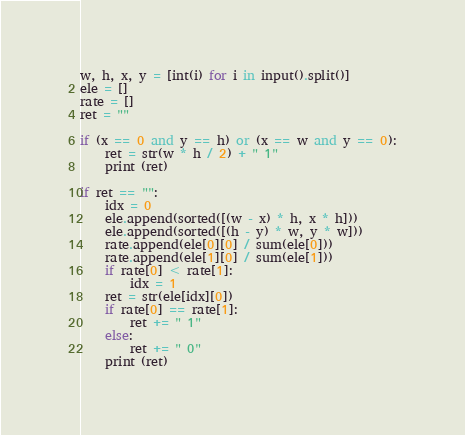Convert code to text. <code><loc_0><loc_0><loc_500><loc_500><_Python_>w, h, x, y = [int(i) for i in input().split()]
ele = []
rate = []
ret = ""

if (x == 0 and y == h) or (x == w and y == 0):
	ret = str(w * h / 2) + " 1"
	print (ret)

if ret == "":
    idx = 0
    ele.append(sorted([(w - x) * h, x * h]))
    ele.append(sorted([(h - y) * w, y * w]))
    rate.append(ele[0][0] / sum(ele[0]))
    rate.append(ele[1][0] / sum(ele[1]))
    if rate[0] < rate[1]:
        idx = 1
    ret = str(ele[idx][0])
    if rate[0] == rate[1]:
        ret += " 1"
    else:
        ret += " 0"
    print (ret)</code> 